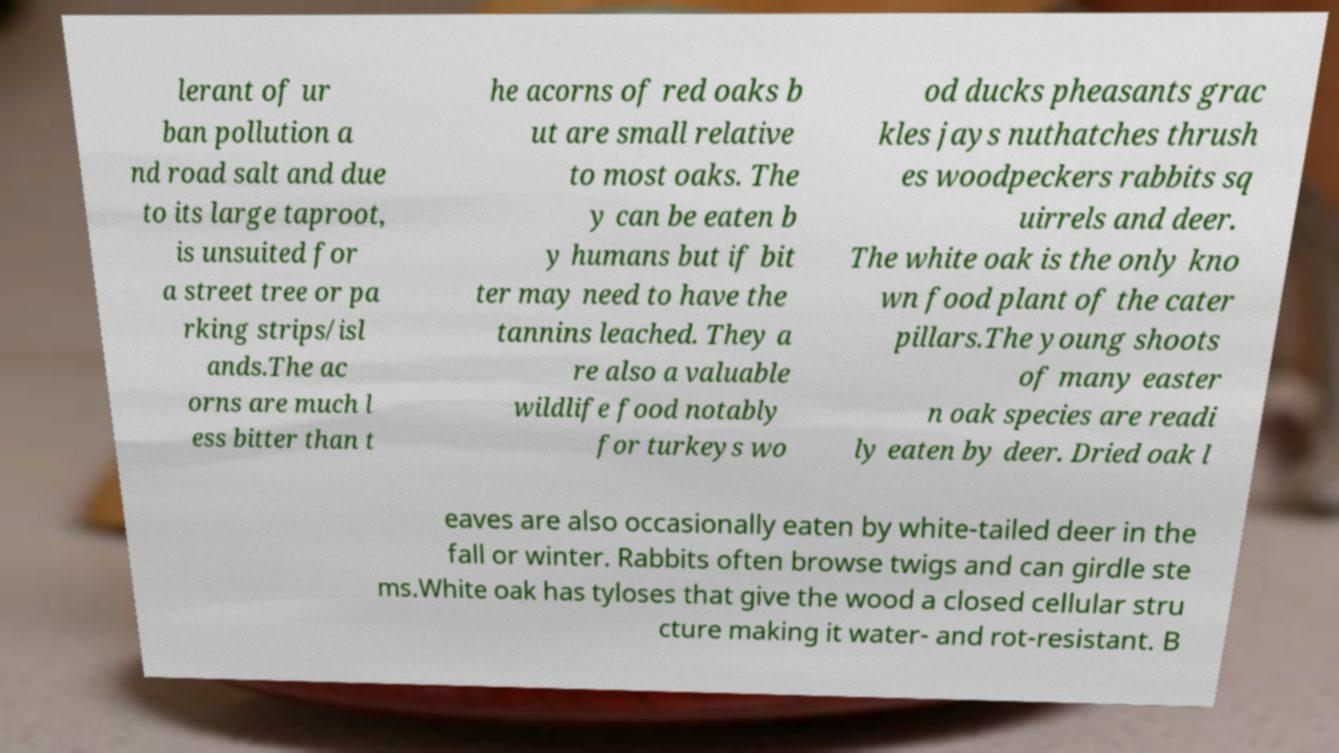Can you read and provide the text displayed in the image?This photo seems to have some interesting text. Can you extract and type it out for me? lerant of ur ban pollution a nd road salt and due to its large taproot, is unsuited for a street tree or pa rking strips/isl ands.The ac orns are much l ess bitter than t he acorns of red oaks b ut are small relative to most oaks. The y can be eaten b y humans but if bit ter may need to have the tannins leached. They a re also a valuable wildlife food notably for turkeys wo od ducks pheasants grac kles jays nuthatches thrush es woodpeckers rabbits sq uirrels and deer. The white oak is the only kno wn food plant of the cater pillars.The young shoots of many easter n oak species are readi ly eaten by deer. Dried oak l eaves are also occasionally eaten by white-tailed deer in the fall or winter. Rabbits often browse twigs and can girdle ste ms.White oak has tyloses that give the wood a closed cellular stru cture making it water- and rot-resistant. B 